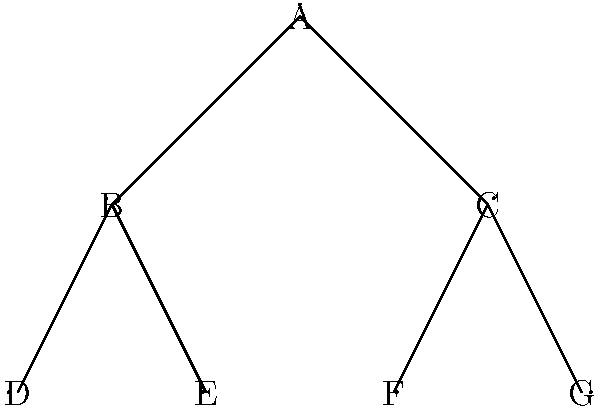Consider the binary tree representing a category hierarchy in WooCommerce. What is the order of the automorphism group of this tree? To determine the order of the automorphism group of this binary tree, we need to follow these steps:

1) First, observe that the root node (A) must remain fixed in any automorphism.

2) The two children of the root (B and C) can be swapped. This gives us 2 possibilities.

3) For each of B and C, their children can also be swapped independently. This gives us 2 possibilities for B's children and 2 for C's children.

4) The total number of automorphisms is the product of these possibilities:

   $2 \times 2 \times 2 = 8$

5) This is because for each choice we make at the top level (swapping B and C or not), we have 2 choices for B's children and 2 choices for C's children.

6) In group theory terms, this automorphism group is isomorphic to $\mathbb{Z}_2 \times \mathbb{Z}_2 \times \mathbb{Z}_2$, where $\mathbb{Z}_2$ is the cyclic group of order 2.

Therefore, the order of the automorphism group of this binary tree is 8.
Answer: 8 